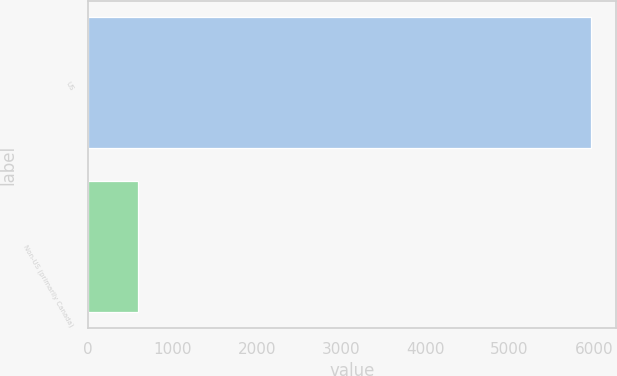Convert chart. <chart><loc_0><loc_0><loc_500><loc_500><bar_chart><fcel>US<fcel>Non-US (primarily Canada)<nl><fcel>5960.9<fcel>587.5<nl></chart> 